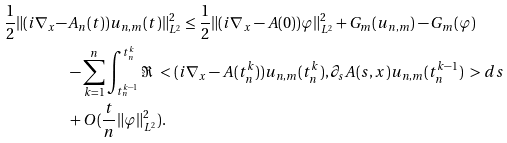Convert formula to latex. <formula><loc_0><loc_0><loc_500><loc_500>\frac { 1 } { 2 } \| ( i \nabla _ { x } - & A _ { n } ( t ) ) u _ { n , m } ( t ) \| _ { L ^ { 2 } } ^ { 2 } \leq \frac { 1 } { 2 } \| ( i \nabla _ { x } - A ( 0 ) ) \varphi \| _ { L ^ { 2 } } ^ { 2 } + G _ { m } ( u _ { n , m } ) - G _ { m } ( \varphi ) \\ & - \sum _ { k = 1 } ^ { n } \int _ { t _ { n } ^ { k - 1 } } ^ { t _ { n } ^ { k } } \Re \ < ( i \nabla _ { x } - A ( t _ { n } ^ { k } ) ) u _ { n , m } ( t _ { n } ^ { k } ) , \partial _ { s } A ( s , x ) u _ { n , m } ( t _ { n } ^ { k - 1 } ) \ > d s \\ & + O ( \frac { t } { n } \| \varphi \| ^ { 2 } _ { L ^ { 2 } } ) .</formula> 